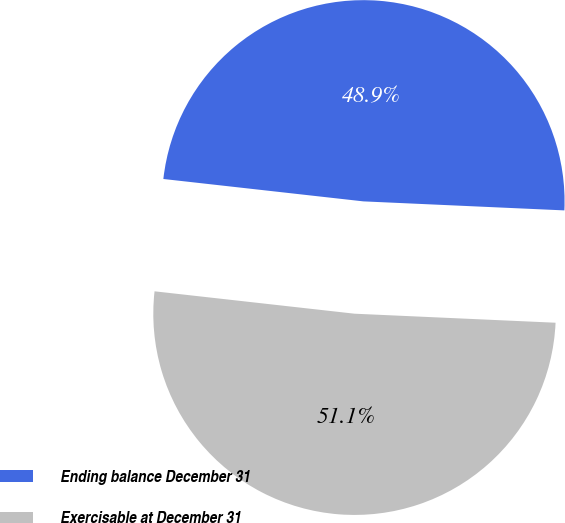<chart> <loc_0><loc_0><loc_500><loc_500><pie_chart><fcel>Ending balance December 31<fcel>Exercisable at December 31<nl><fcel>48.94%<fcel>51.06%<nl></chart> 